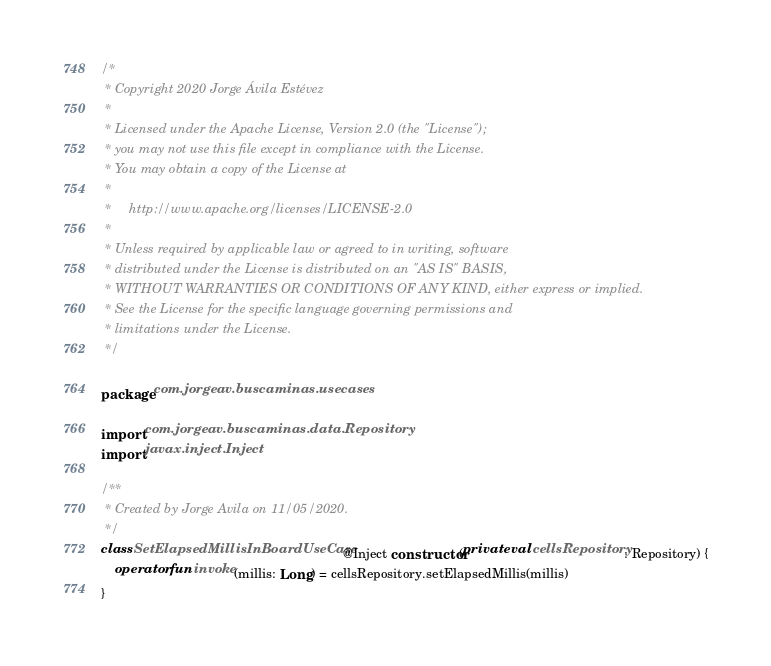Convert code to text. <code><loc_0><loc_0><loc_500><loc_500><_Kotlin_>/*
 * Copyright 2020 Jorge Ávila Estévez
 *
 * Licensed under the Apache License, Version 2.0 (the "License");
 * you may not use this file except in compliance with the License.
 * You may obtain a copy of the License at
 *
 *     http://www.apache.org/licenses/LICENSE-2.0
 *
 * Unless required by applicable law or agreed to in writing, software
 * distributed under the License is distributed on an "AS IS" BASIS,
 * WITHOUT WARRANTIES OR CONDITIONS OF ANY KIND, either express or implied.
 * See the License for the specific language governing permissions and
 * limitations under the License.
 */

package com.jorgeav.buscaminas.usecases

import com.jorgeav.buscaminas.data.Repository
import javax.inject.Inject

/**
 * Created by Jorge Avila on 11/05/2020.
 */
class SetElapsedMillisInBoardUseCase @Inject constructor(private val cellsRepository: Repository) {
    operator fun invoke(millis: Long) = cellsRepository.setElapsedMillis(millis)
}</code> 